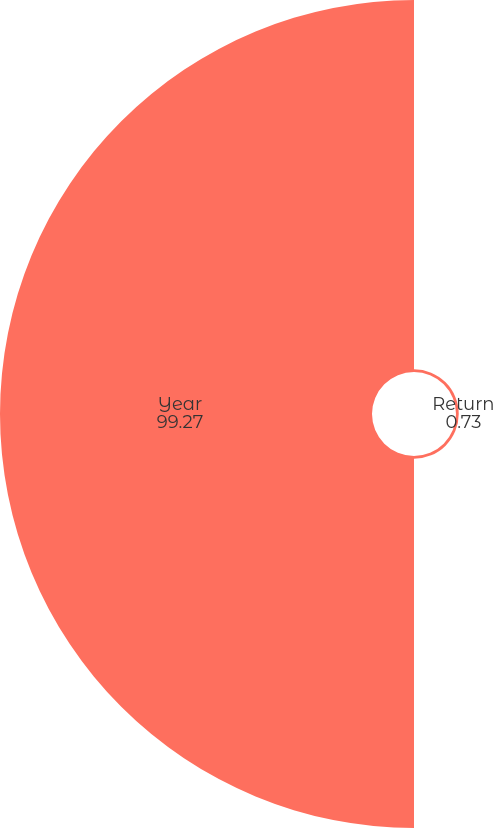<chart> <loc_0><loc_0><loc_500><loc_500><pie_chart><fcel>Return<fcel>Year<nl><fcel>0.73%<fcel>99.27%<nl></chart> 